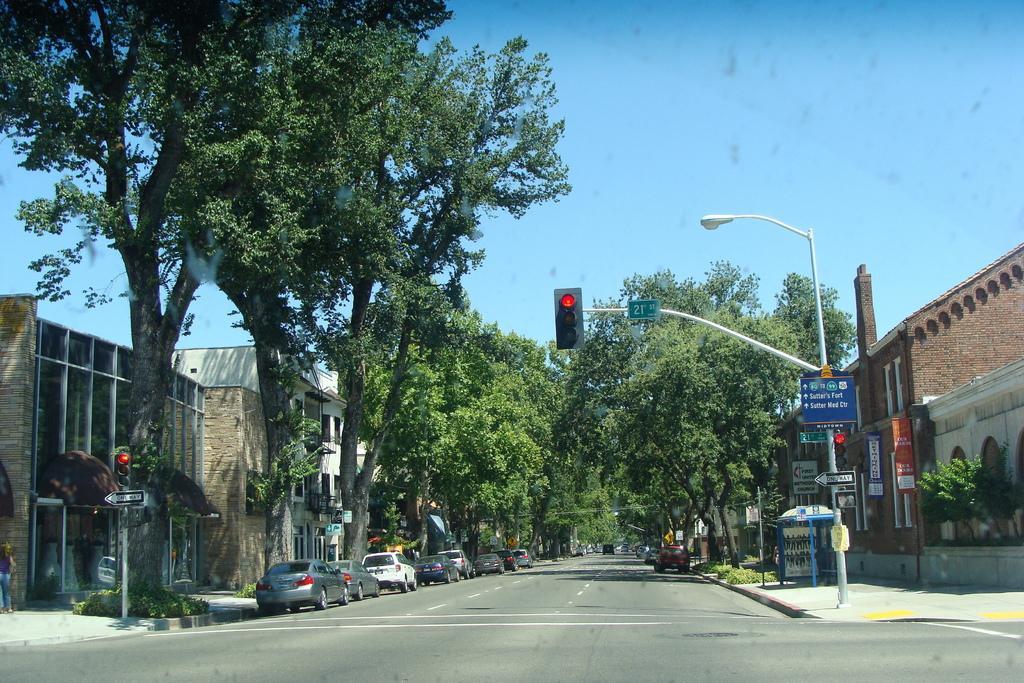In one or two sentences, can you explain what this image depicts? In this image we can see vehicles, trees and plants. Beside the trees we can see the buildings. On the right side, we can see boards on the buildings. In the foreground we can see the poles with traffic lights and boards. At the top we can see the sky. 